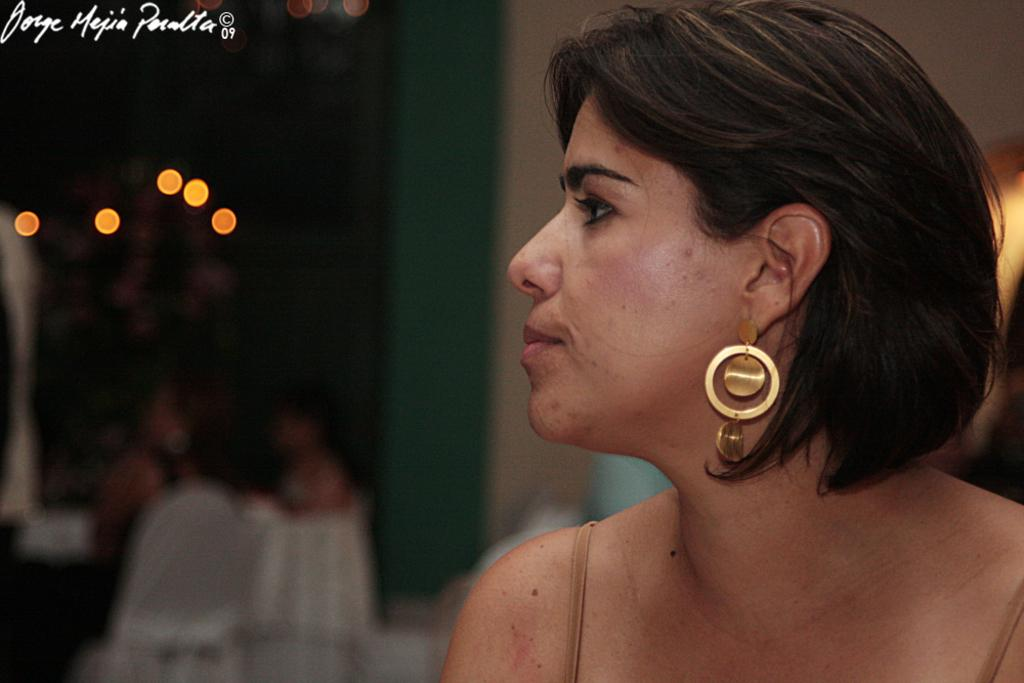Who is on the right side of the image? There is a woman on the right side of the image. What objects are present in the image for sitting? There are chairs in the image. What is the background of the image made of? There is a wall in the image. What is providing illumination in the image? There are lights in the image. How would you describe the clarity of the image? The image is blurred. What type of stew is being prepared in the image? There is no stew present in the image; it does not depict any cooking or food preparation. 